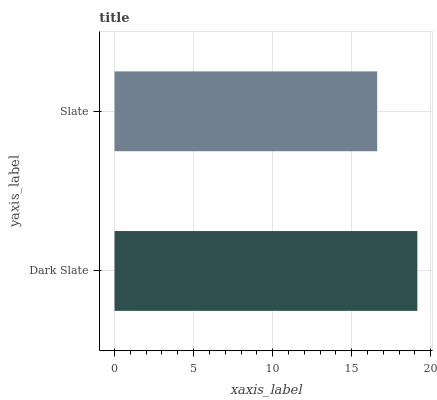Is Slate the minimum?
Answer yes or no. Yes. Is Dark Slate the maximum?
Answer yes or no. Yes. Is Slate the maximum?
Answer yes or no. No. Is Dark Slate greater than Slate?
Answer yes or no. Yes. Is Slate less than Dark Slate?
Answer yes or no. Yes. Is Slate greater than Dark Slate?
Answer yes or no. No. Is Dark Slate less than Slate?
Answer yes or no. No. Is Dark Slate the high median?
Answer yes or no. Yes. Is Slate the low median?
Answer yes or no. Yes. Is Slate the high median?
Answer yes or no. No. Is Dark Slate the low median?
Answer yes or no. No. 